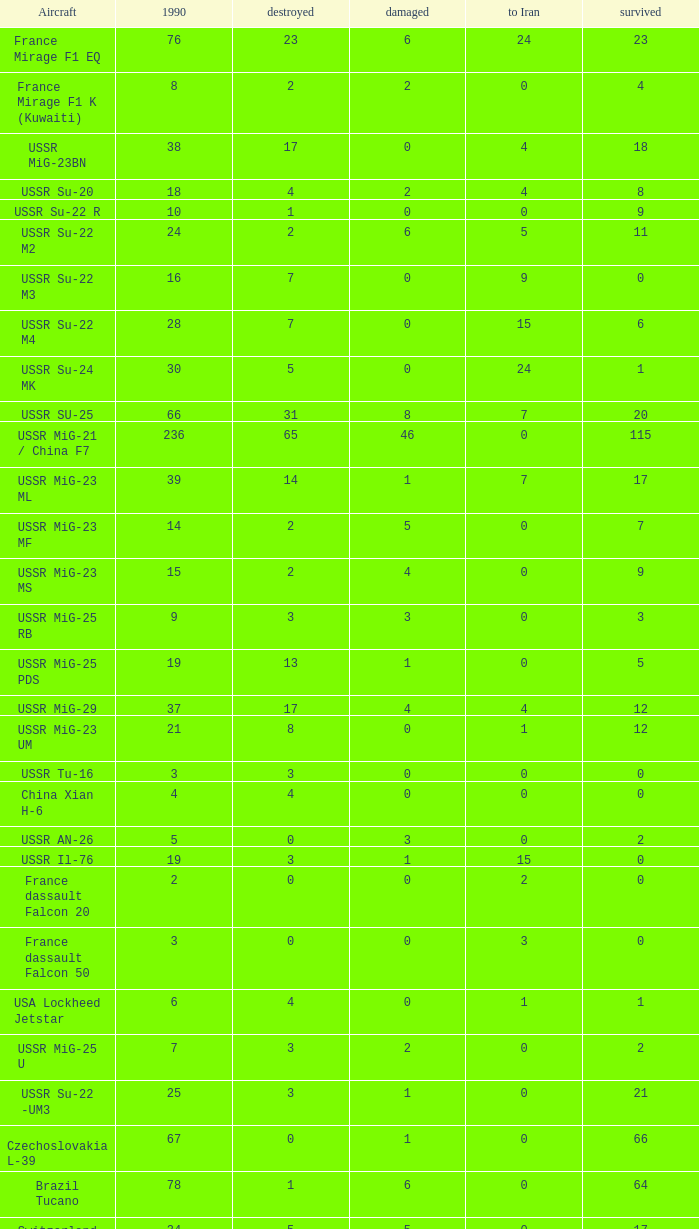If 4 went to iran and the amount that survived was less than 12.0 how many were there in 1990? 1.0. 